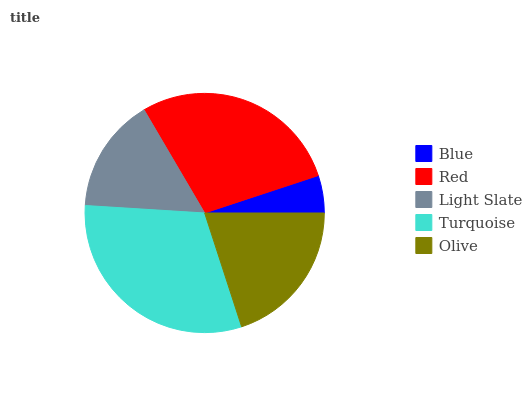Is Blue the minimum?
Answer yes or no. Yes. Is Turquoise the maximum?
Answer yes or no. Yes. Is Red the minimum?
Answer yes or no. No. Is Red the maximum?
Answer yes or no. No. Is Red greater than Blue?
Answer yes or no. Yes. Is Blue less than Red?
Answer yes or no. Yes. Is Blue greater than Red?
Answer yes or no. No. Is Red less than Blue?
Answer yes or no. No. Is Olive the high median?
Answer yes or no. Yes. Is Olive the low median?
Answer yes or no. Yes. Is Turquoise the high median?
Answer yes or no. No. Is Turquoise the low median?
Answer yes or no. No. 